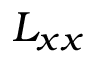<formula> <loc_0><loc_0><loc_500><loc_500>L _ { x x }</formula> 